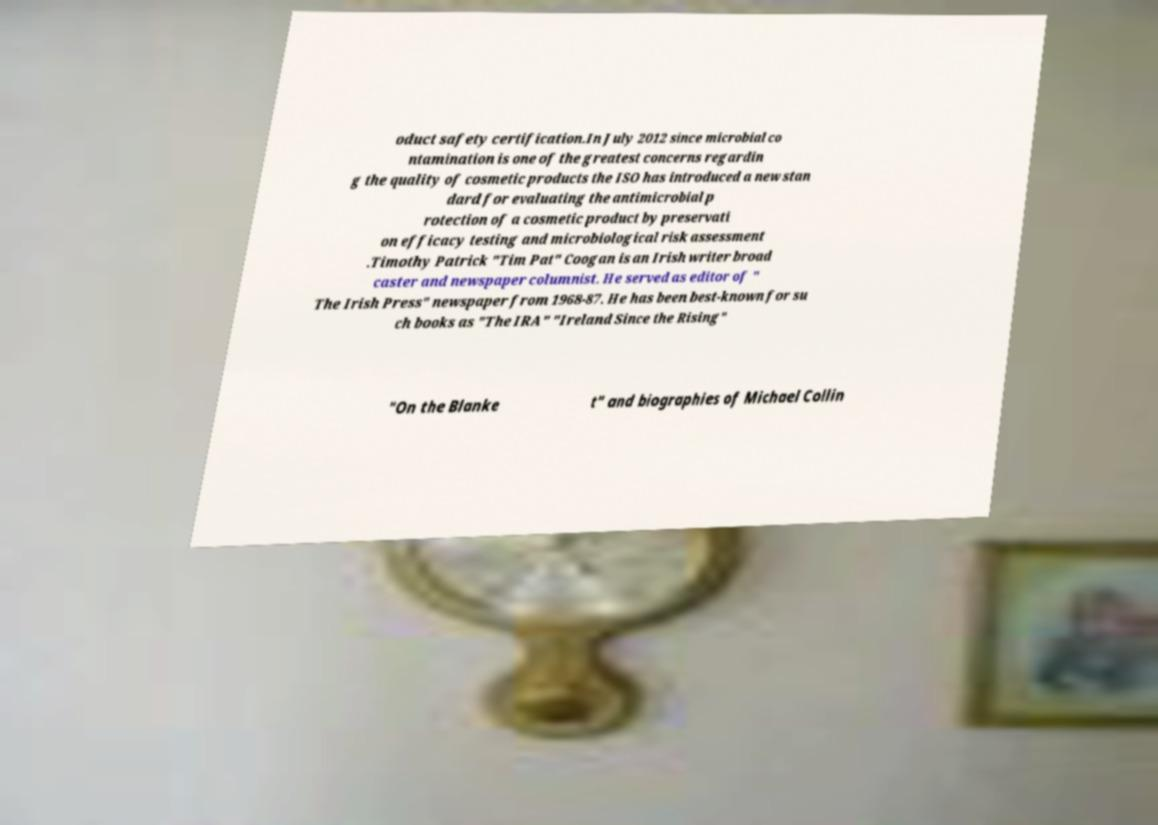Can you read and provide the text displayed in the image?This photo seems to have some interesting text. Can you extract and type it out for me? oduct safety certification.In July 2012 since microbial co ntamination is one of the greatest concerns regardin g the quality of cosmetic products the ISO has introduced a new stan dard for evaluating the antimicrobial p rotection of a cosmetic product by preservati on efficacy testing and microbiological risk assessment .Timothy Patrick "Tim Pat" Coogan is an Irish writer broad caster and newspaper columnist. He served as editor of " The Irish Press" newspaper from 1968-87. He has been best-known for su ch books as "The IRA" "Ireland Since the Rising" "On the Blanke t" and biographies of Michael Collin 